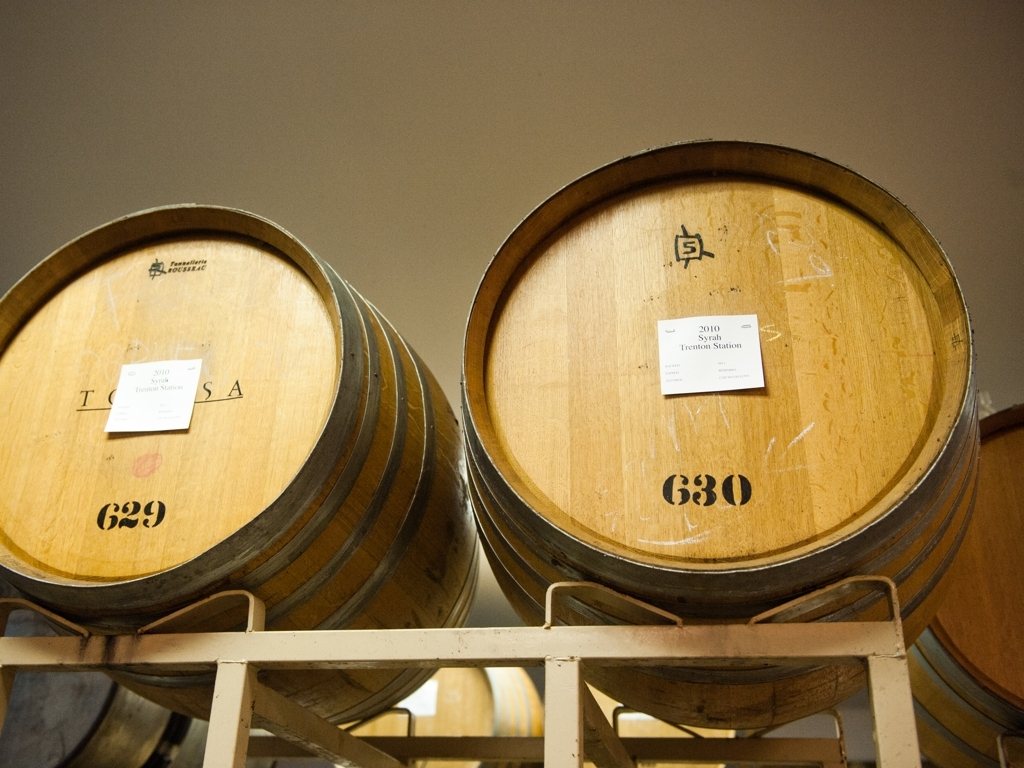Can you explain the significance of the labels on the barrels? The labels on the barrels are critical for identifying the contents. They indicate the source of the wine ('Eoinetta Natura' and 'Trenton Station'), as well as the vintage ('2019' and '2010'), which refers to the year the grapes were harvested. This information is important for tracking the maturation of the wine and for understanding its provenance and potential flavor profile. Why would the vintage year be important to know? The vintage year is critical because it reflects the conditions under which the grapes were grown, including weather patterns, temperature, and precipitation. These factors can significantly influence the quality and characteristics of the wine. Collectors and connoisseurs often seek specific vintages that are known for their exceptional quality or unique traits. 